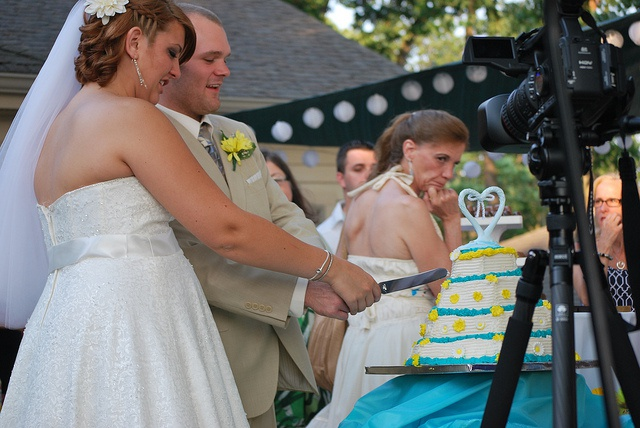Describe the objects in this image and their specific colors. I can see people in darkblue, lightgray, darkgray, and brown tones, people in darkblue, gray, and darkgray tones, people in darkblue, darkgray, brown, tan, and gray tones, cake in darkblue, darkgray, lightgray, teal, and lightblue tones, and people in darkblue, brown, black, and tan tones in this image. 